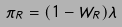<formula> <loc_0><loc_0><loc_500><loc_500>\pi _ { R } = ( 1 - W _ { R } ) \lambda</formula> 